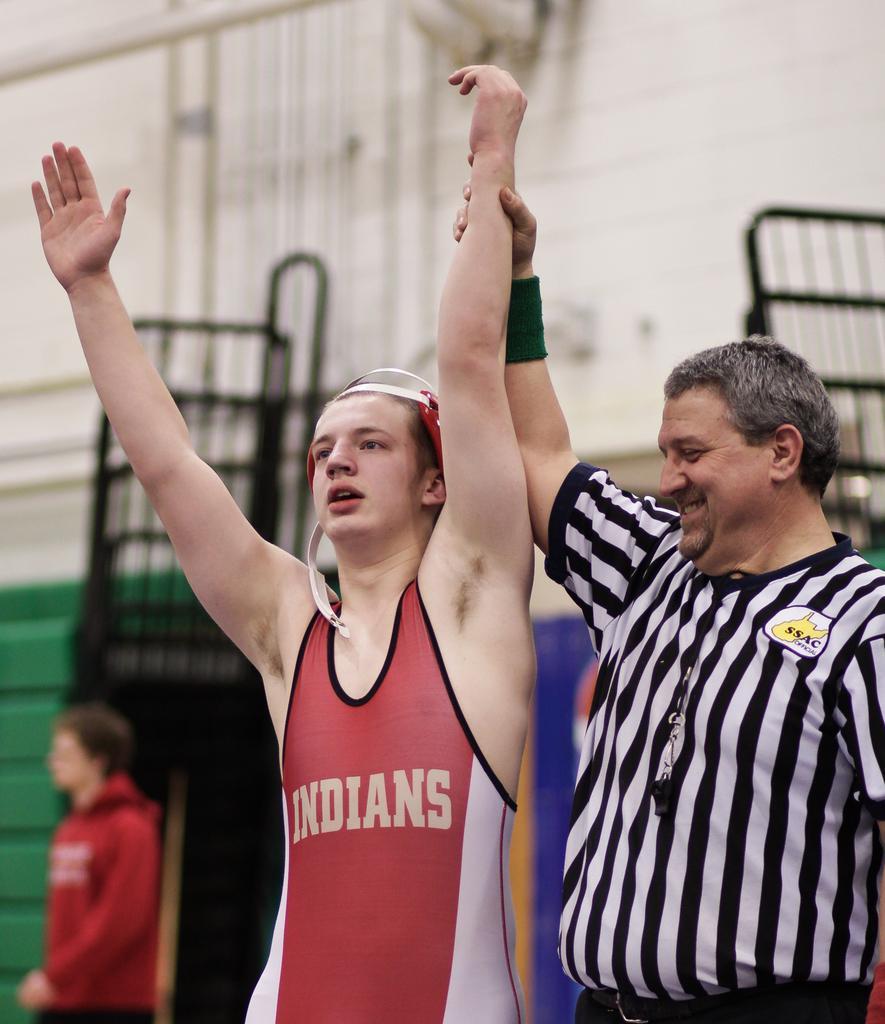Can you describe this image briefly? This picture is clicked inside. On the right we can see the two persons standing and on the left there is another person. In the background we can see the wall, metal rods and some other objects. 